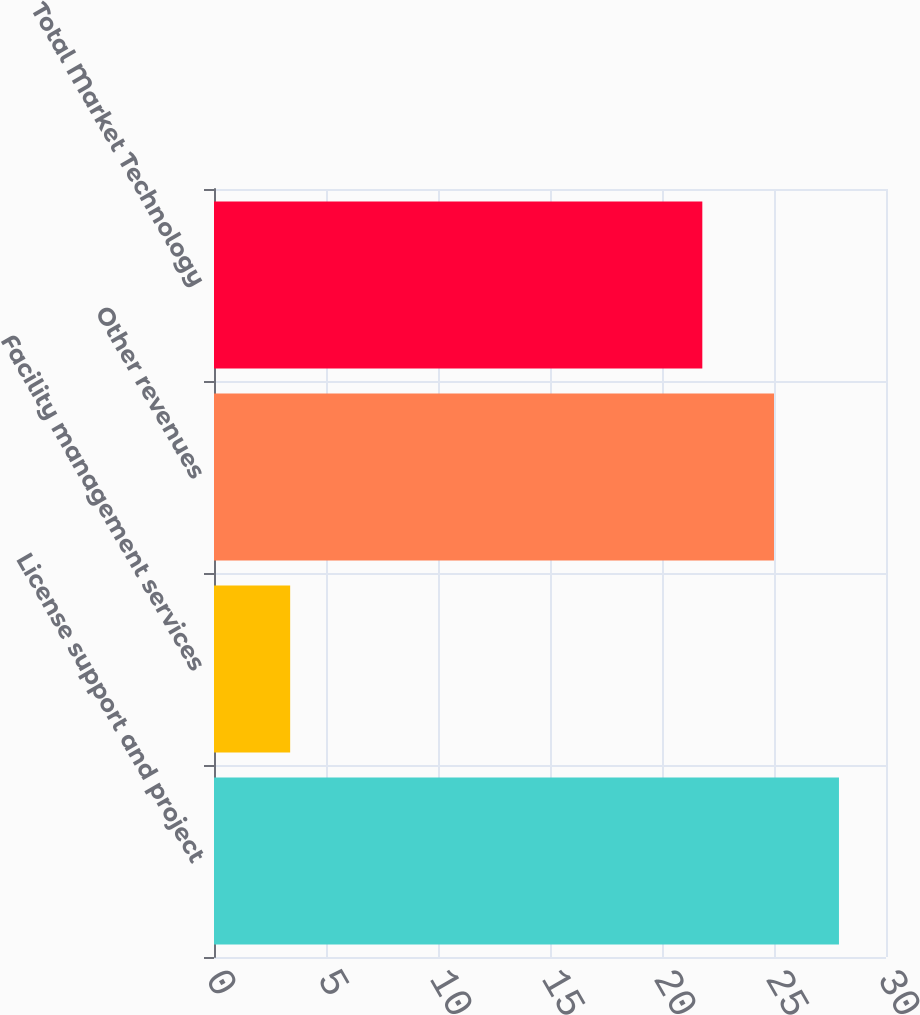<chart> <loc_0><loc_0><loc_500><loc_500><bar_chart><fcel>License support and project<fcel>Facility management services<fcel>Other revenues<fcel>Total Market Technology<nl><fcel>27.9<fcel>3.4<fcel>25<fcel>21.8<nl></chart> 